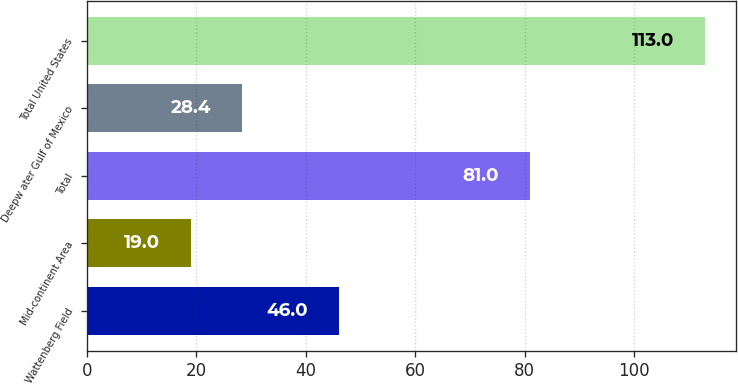<chart> <loc_0><loc_0><loc_500><loc_500><bar_chart><fcel>Wattenberg Field<fcel>Mid-continent Area<fcel>Total<fcel>Deepw ater Gulf of Mexico<fcel>Total United States<nl><fcel>46<fcel>19<fcel>81<fcel>28.4<fcel>113<nl></chart> 